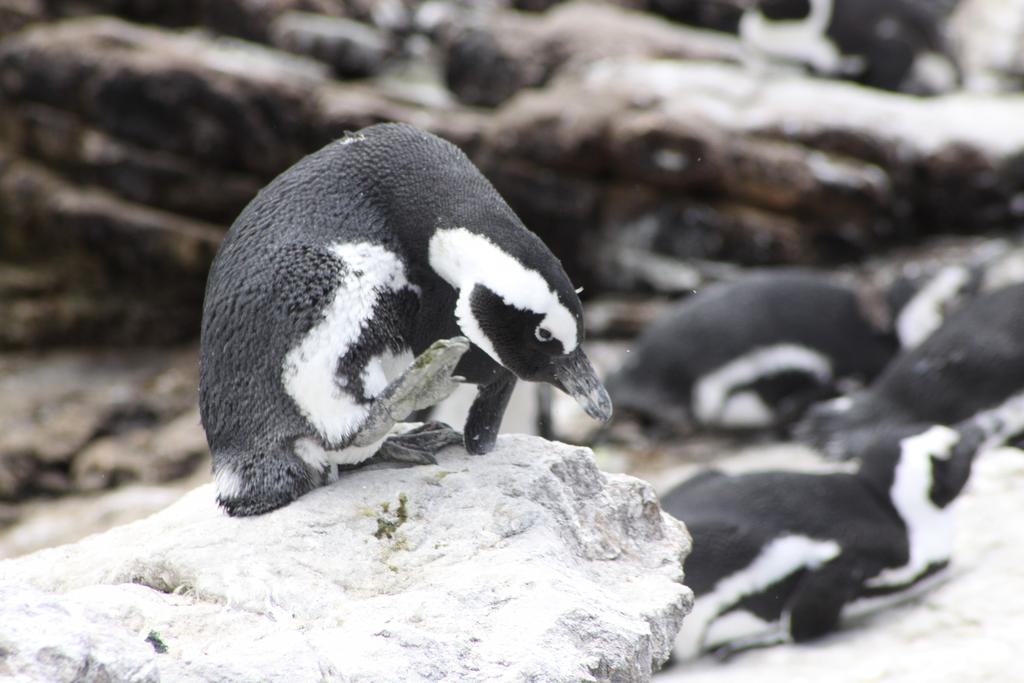What animal is sitting on a stone in the image? There is a penguin sitting on a stone in the image. Are there any other penguins visible in the image? Yes, there are additional penguins on the right side of the image. What type of thumb can be seen holding a banana in the image? There is no thumb or banana present in the image; it features penguins sitting on stones. What is the penguin cooking on the pan in the image? There is no pan or cooking activity present in the image; it features penguins sitting on stones. 